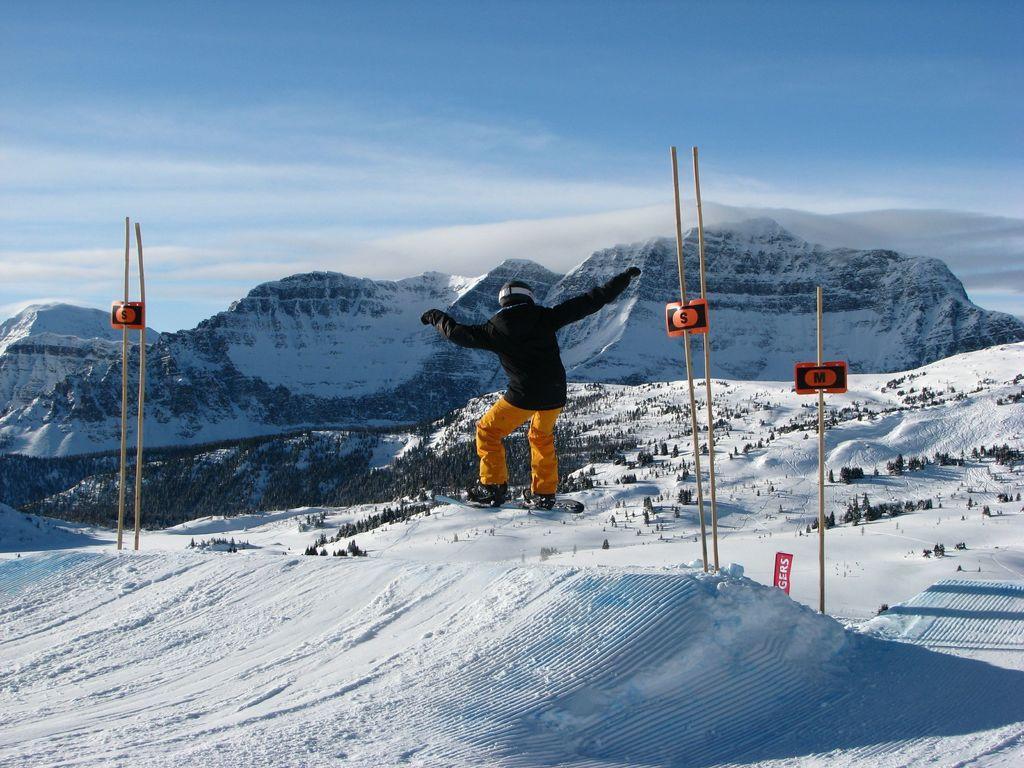Describe this image in one or two sentences. As we can see in the image there is a person skating, snow, sticks, hills, sky and clouds. 